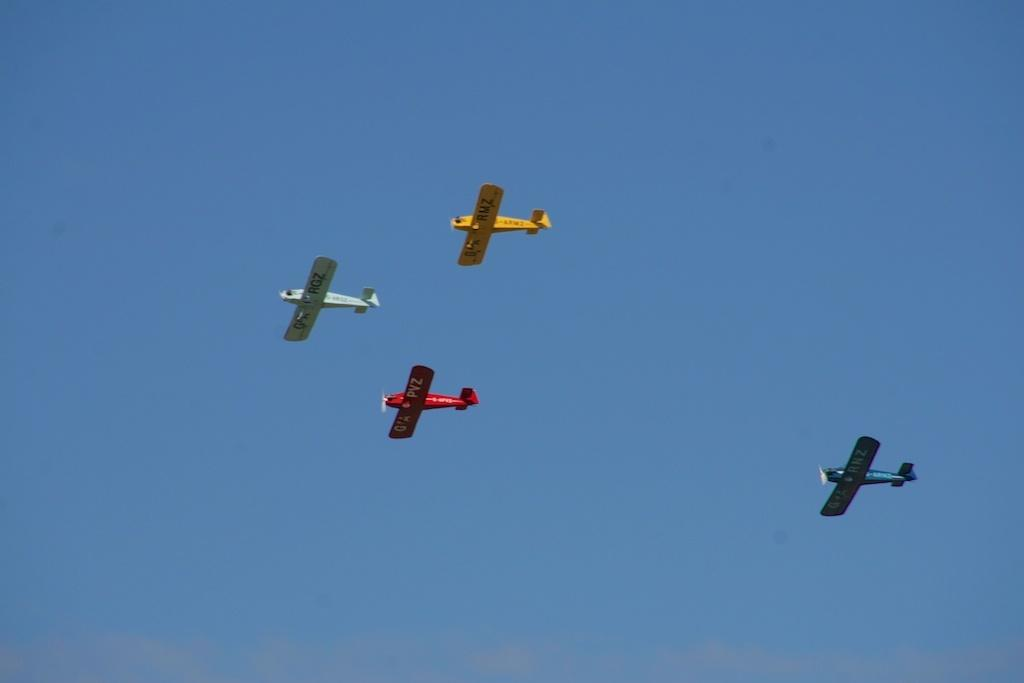What is the main subject of the image? The main subject of the image is aeroplanes. Where are the aeroplanes located in the image? The aeroplanes are in the air in the image. What color is the sky in the image? The sky is blue in the image. What type of winter sport is being played in the image? There is no winter sport or any indication of winter in the image; it features aeroplanes in the air with a blue sky. What team is responsible for flying the aeroplanes in the image? There is no specific team mentioned or depicted in the image; it simply shows aeroplanes in the air. 